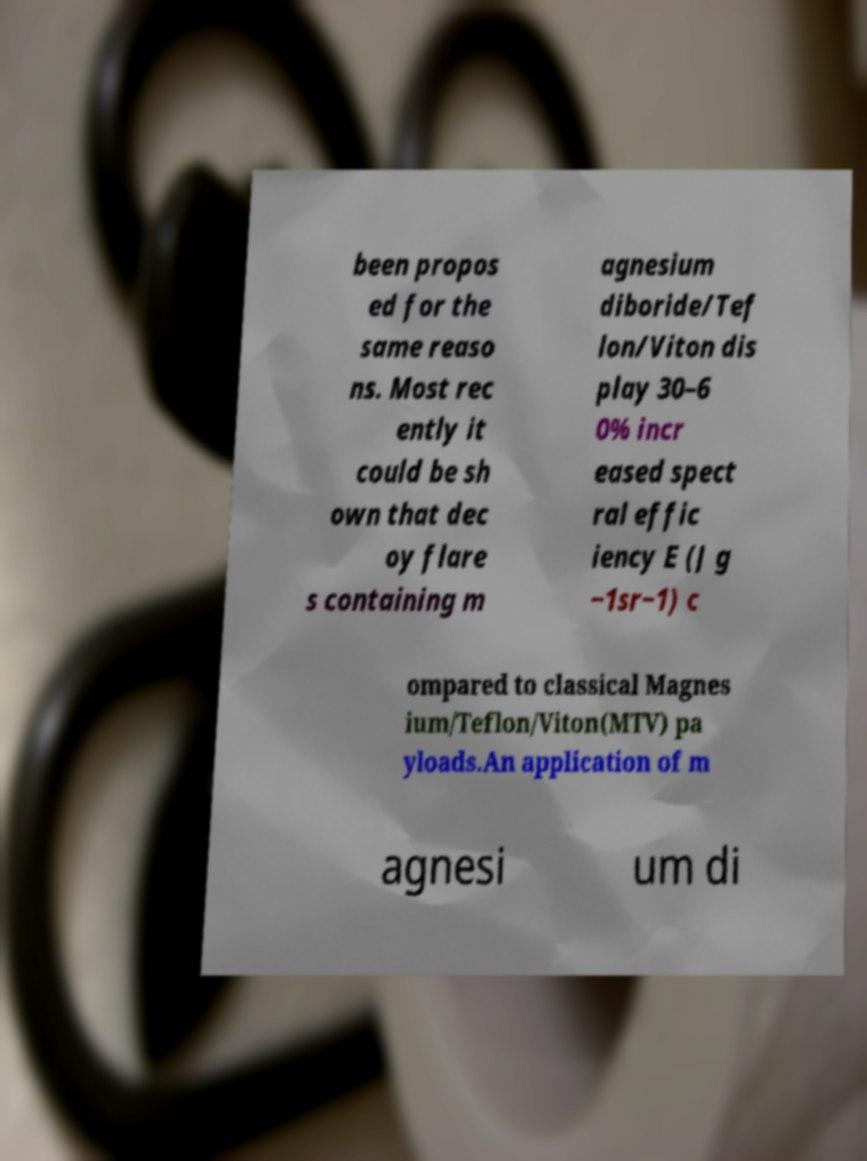For documentation purposes, I need the text within this image transcribed. Could you provide that? been propos ed for the same reaso ns. Most rec ently it could be sh own that dec oy flare s containing m agnesium diboride/Tef lon/Viton dis play 30–6 0% incr eased spect ral effic iency E (J g −1sr−1) c ompared to classical Magnes ium/Teflon/Viton(MTV) pa yloads.An application of m agnesi um di 